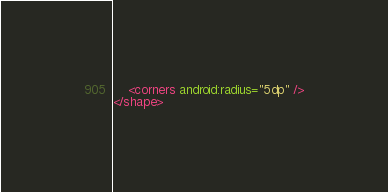Convert code to text. <code><loc_0><loc_0><loc_500><loc_500><_XML_>    <corners android:radius="5dp" />
</shape></code> 